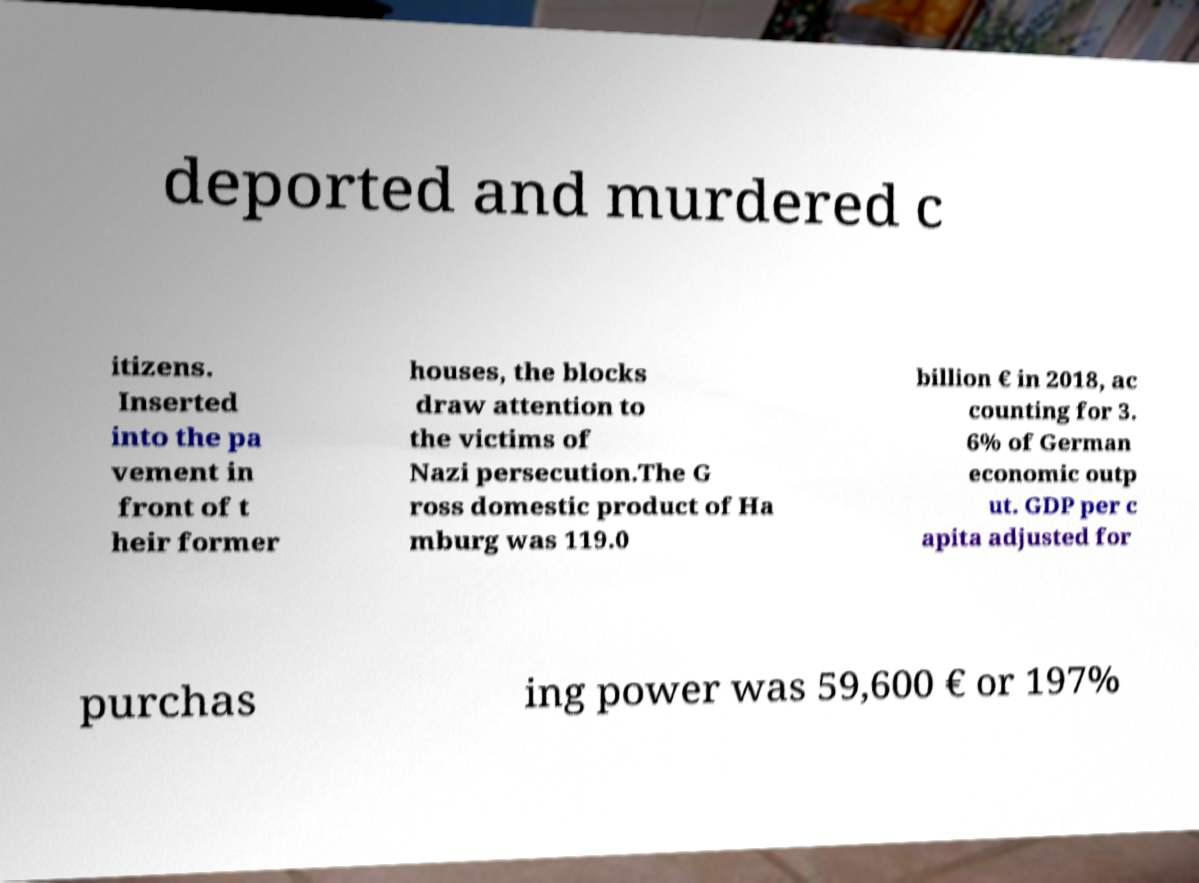There's text embedded in this image that I need extracted. Can you transcribe it verbatim? deported and murdered c itizens. Inserted into the pa vement in front of t heir former houses, the blocks draw attention to the victims of Nazi persecution.The G ross domestic product of Ha mburg was 119.0 billion € in 2018, ac counting for 3. 6% of German economic outp ut. GDP per c apita adjusted for purchas ing power was 59,600 € or 197% 